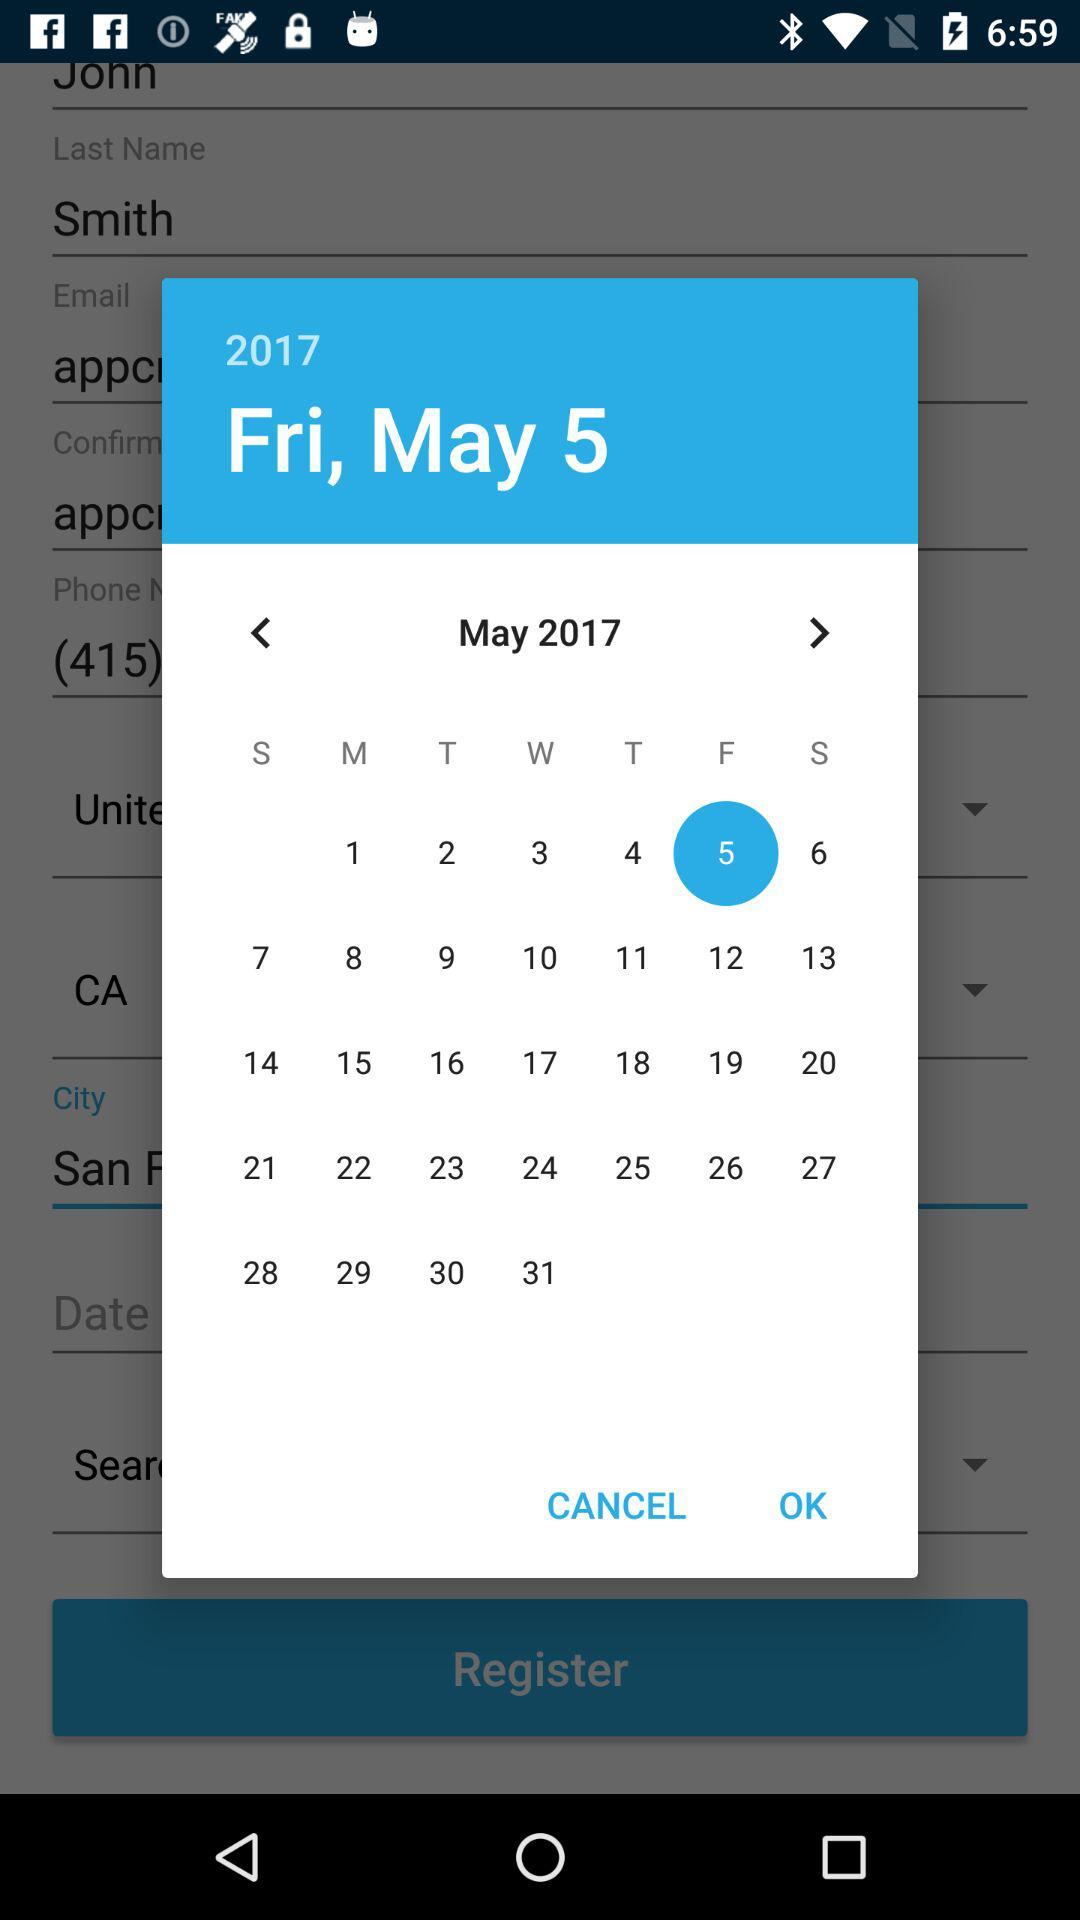How old is the user?
When the provided information is insufficient, respond with <no answer>. <no answer> 